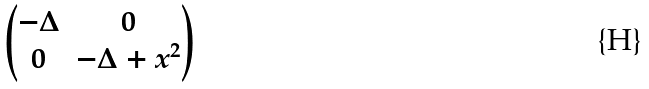Convert formula to latex. <formula><loc_0><loc_0><loc_500><loc_500>\begin{pmatrix} - \Delta & 0 \\ 0 & - \Delta + x ^ { 2 } \end{pmatrix}</formula> 